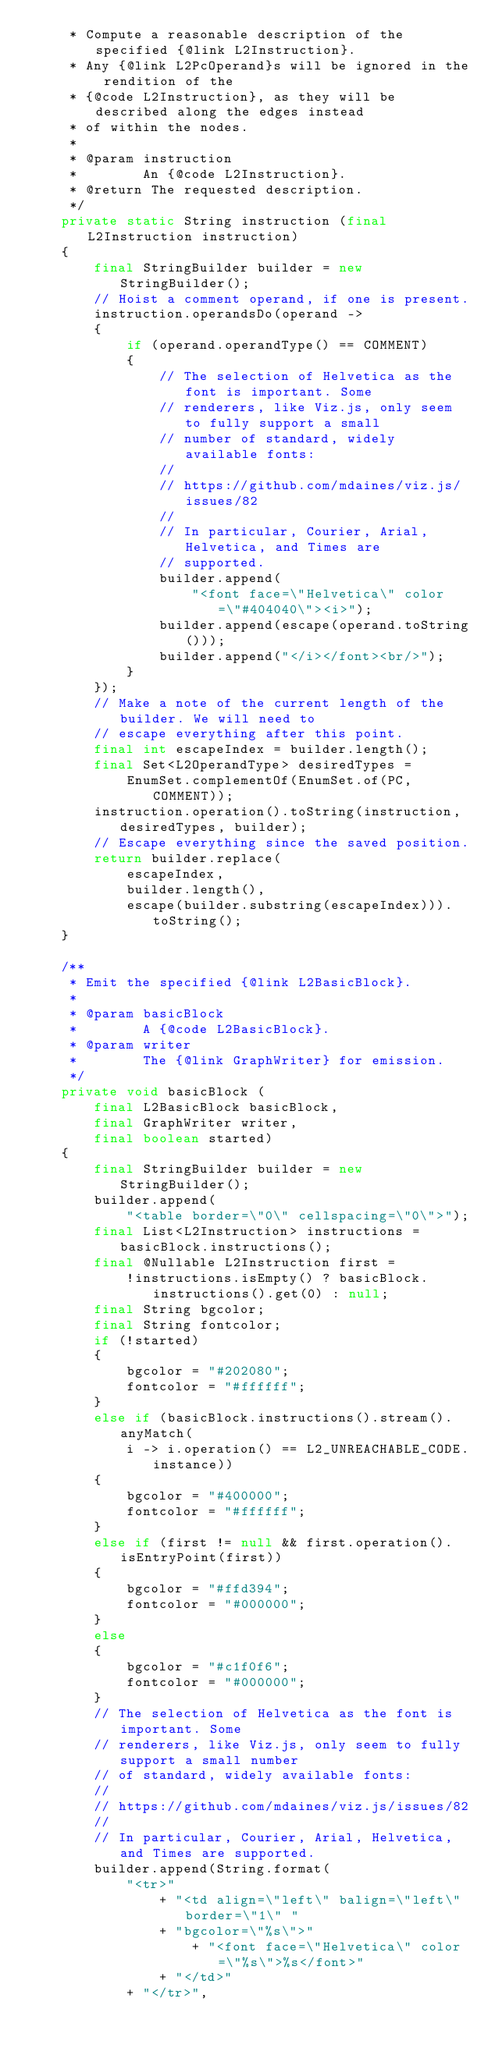Convert code to text. <code><loc_0><loc_0><loc_500><loc_500><_Java_>	 * Compute a reasonable description of the specified {@link L2Instruction}.
	 * Any {@link L2PcOperand}s will be ignored in the rendition of the
	 * {@code L2Instruction}, as they will be described along the edges instead
	 * of within the nodes.
	 *
	 * @param instruction
	 *        An {@code L2Instruction}.
	 * @return The requested description.
	 */
	private static String instruction (final L2Instruction instruction)
	{
		final StringBuilder builder = new StringBuilder();
		// Hoist a comment operand, if one is present.
		instruction.operandsDo(operand ->
		{
			if (operand.operandType() == COMMENT)
			{
				// The selection of Helvetica as the font is important. Some
				// renderers, like Viz.js, only seem to fully support a small
				// number of standard, widely available fonts:
				//
				// https://github.com/mdaines/viz.js/issues/82
				//
				// In particular, Courier, Arial, Helvetica, and Times are
				// supported.
				builder.append(
					"<font face=\"Helvetica\" color=\"#404040\"><i>");
				builder.append(escape(operand.toString()));
				builder.append("</i></font><br/>");
			}
		});
		// Make a note of the current length of the builder. We will need to
		// escape everything after this point.
		final int escapeIndex = builder.length();
		final Set<L2OperandType> desiredTypes =
			EnumSet.complementOf(EnumSet.of(PC, COMMENT));
		instruction.operation().toString(instruction, desiredTypes, builder);
		// Escape everything since the saved position.
		return builder.replace(
			escapeIndex,
			builder.length(),
			escape(builder.substring(escapeIndex))).toString();
	}

	/**
	 * Emit the specified {@link L2BasicBlock}.
	 *
	 * @param basicBlock
	 *        A {@code L2BasicBlock}.
	 * @param writer
	 *        The {@link GraphWriter} for emission.
	 */
	private void basicBlock (
		final L2BasicBlock basicBlock,
		final GraphWriter writer,
		final boolean started)
	{
		final StringBuilder builder = new StringBuilder();
		builder.append(
			"<table border=\"0\" cellspacing=\"0\">");
		final List<L2Instruction> instructions = basicBlock.instructions();
		final @Nullable L2Instruction first =
			!instructions.isEmpty() ? basicBlock.instructions().get(0) : null;
		final String bgcolor;
		final String fontcolor;
		if (!started)
		{
			bgcolor = "#202080";
			fontcolor = "#ffffff";
		}
		else if (basicBlock.instructions().stream().anyMatch(
			i -> i.operation() == L2_UNREACHABLE_CODE.instance))
		{
			bgcolor = "#400000";
			fontcolor = "#ffffff";
		}
		else if (first != null && first.operation().isEntryPoint(first))
		{
			bgcolor = "#ffd394";
			fontcolor = "#000000";
		}
		else
		{
			bgcolor = "#c1f0f6";
			fontcolor = "#000000";
		}
		// The selection of Helvetica as the font is important. Some
		// renderers, like Viz.js, only seem to fully support a small number
		// of standard, widely available fonts:
		//
		// https://github.com/mdaines/viz.js/issues/82
		//
		// In particular, Courier, Arial, Helvetica, and Times are supported.
		builder.append(String.format(
			"<tr>"
				+ "<td align=\"left\" balign=\"left\" border=\"1\" "
				+ "bgcolor=\"%s\">"
					+ "<font face=\"Helvetica\" color=\"%s\">%s</font>"
				+ "</td>"
			+ "</tr>",</code> 